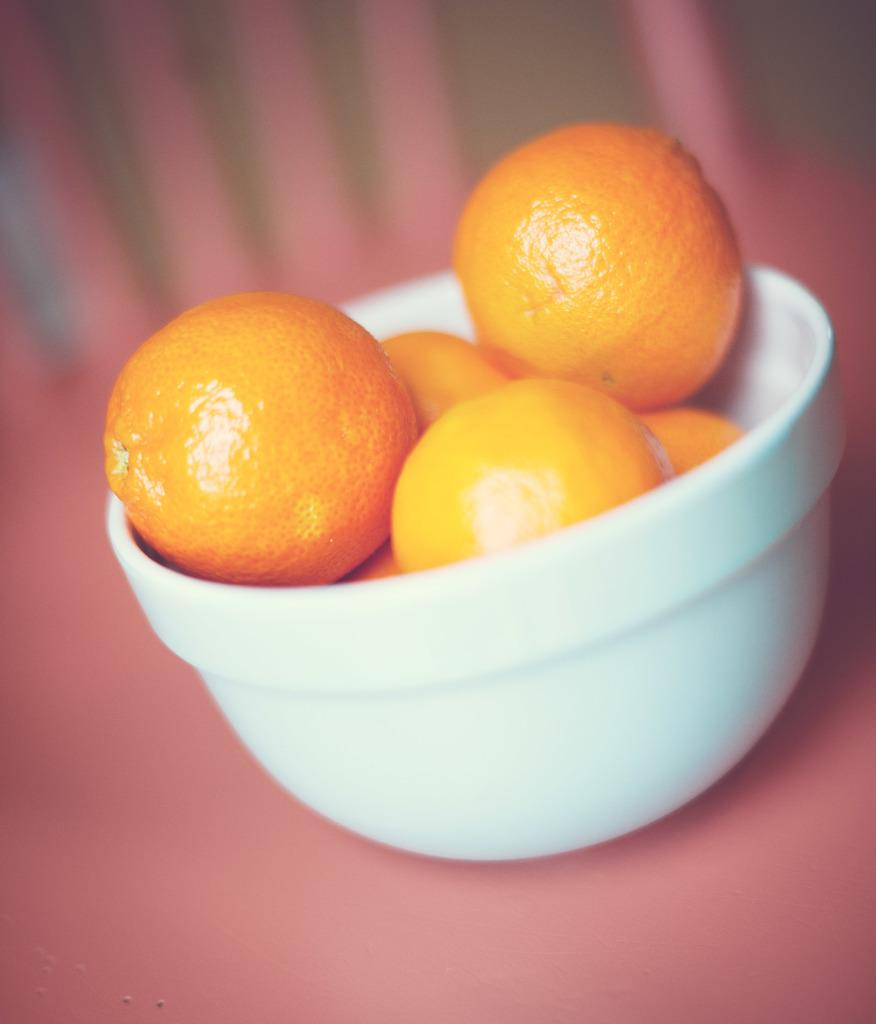What color is the surface in the image? The surface in the image is pink. What is placed on the pink surface? There is a bowl on the pink surface. What is inside the bowl? There are oranges in the bowl. Can you describe the background of the image? The background of the image is blurred. What type of fiction is being read by the oranges in the image? There is no indication in the image that the oranges are reading any fiction, as oranges are not capable of reading. 